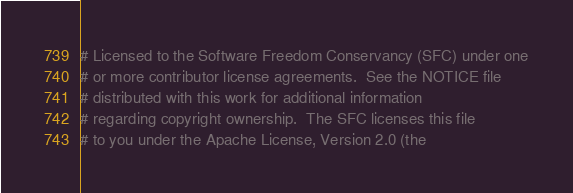Convert code to text. <code><loc_0><loc_0><loc_500><loc_500><_Python_># Licensed to the Software Freedom Conservancy (SFC) under one
# or more contributor license agreements.  See the NOTICE file
# distributed with this work for additional information
# regarding copyright ownership.  The SFC licenses this file
# to you under the Apache License, Version 2.0 (the</code> 